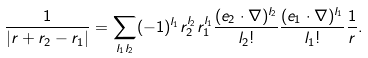<formula> <loc_0><loc_0><loc_500><loc_500>\frac { 1 } { | { r } + { r } _ { 2 } - { r } _ { 1 } | } = \sum _ { l _ { 1 } l _ { 2 } } ( - 1 ) ^ { l _ { 1 } } r _ { 2 } ^ { l _ { 2 } } r _ { 1 } ^ { l _ { 1 } } \frac { ( { e } _ { 2 } \cdot \nabla ) ^ { l _ { 2 } } } { l _ { 2 } ! } \frac { ( { e } _ { 1 } \cdot \nabla ) ^ { l _ { 1 } } } { l _ { 1 } ! } \frac { 1 } { r } .</formula> 